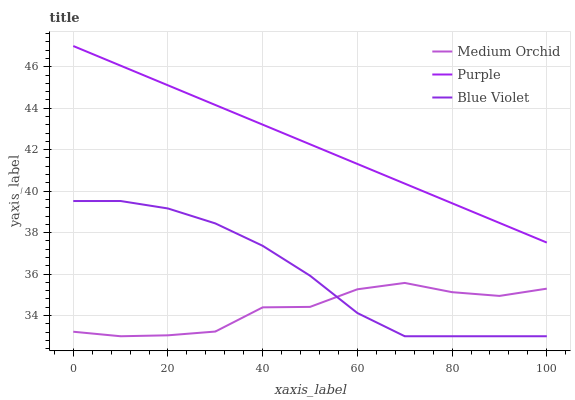Does Medium Orchid have the minimum area under the curve?
Answer yes or no. Yes. Does Purple have the maximum area under the curve?
Answer yes or no. Yes. Does Blue Violet have the minimum area under the curve?
Answer yes or no. No. Does Blue Violet have the maximum area under the curve?
Answer yes or no. No. Is Purple the smoothest?
Answer yes or no. Yes. Is Medium Orchid the roughest?
Answer yes or no. Yes. Is Blue Violet the smoothest?
Answer yes or no. No. Is Blue Violet the roughest?
Answer yes or no. No. Does Medium Orchid have the lowest value?
Answer yes or no. Yes. Does Purple have the highest value?
Answer yes or no. Yes. Does Blue Violet have the highest value?
Answer yes or no. No. Is Medium Orchid less than Purple?
Answer yes or no. Yes. Is Purple greater than Medium Orchid?
Answer yes or no. Yes. Does Medium Orchid intersect Blue Violet?
Answer yes or no. Yes. Is Medium Orchid less than Blue Violet?
Answer yes or no. No. Is Medium Orchid greater than Blue Violet?
Answer yes or no. No. Does Medium Orchid intersect Purple?
Answer yes or no. No. 